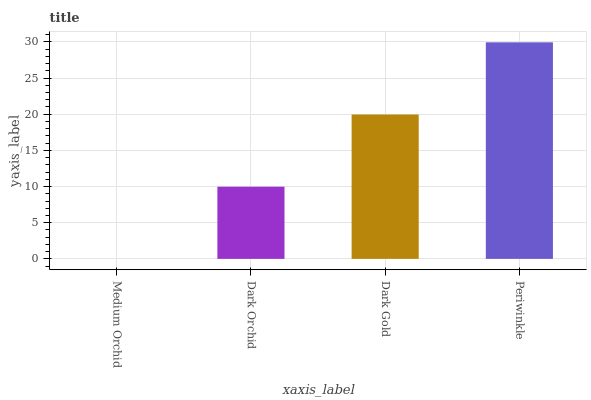Is Dark Orchid the minimum?
Answer yes or no. No. Is Dark Orchid the maximum?
Answer yes or no. No. Is Dark Orchid greater than Medium Orchid?
Answer yes or no. Yes. Is Medium Orchid less than Dark Orchid?
Answer yes or no. Yes. Is Medium Orchid greater than Dark Orchid?
Answer yes or no. No. Is Dark Orchid less than Medium Orchid?
Answer yes or no. No. Is Dark Gold the high median?
Answer yes or no. Yes. Is Dark Orchid the low median?
Answer yes or no. Yes. Is Periwinkle the high median?
Answer yes or no. No. Is Medium Orchid the low median?
Answer yes or no. No. 